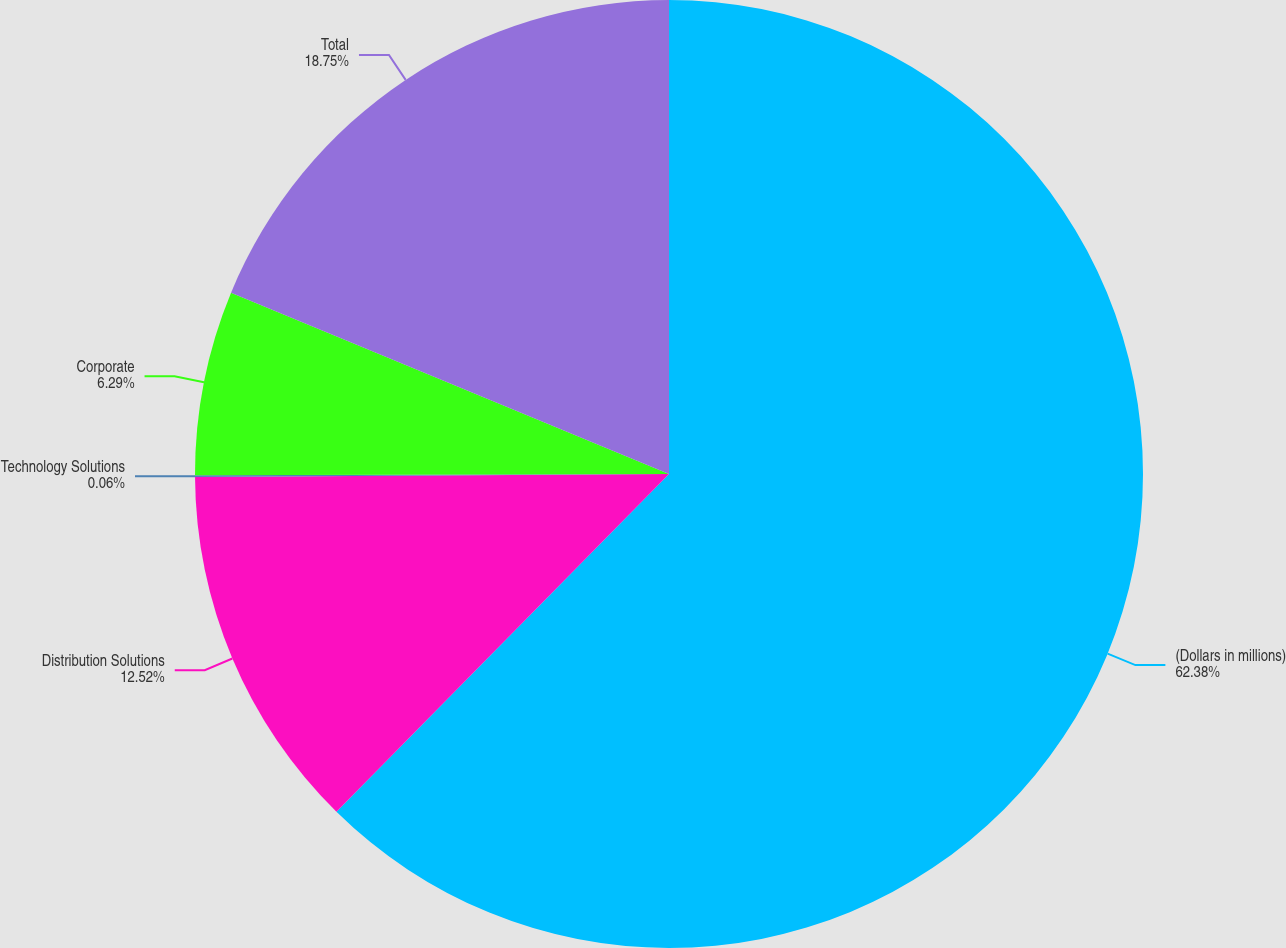Convert chart to OTSL. <chart><loc_0><loc_0><loc_500><loc_500><pie_chart><fcel>(Dollars in millions)<fcel>Distribution Solutions<fcel>Technology Solutions<fcel>Corporate<fcel>Total<nl><fcel>62.37%<fcel>12.52%<fcel>0.06%<fcel>6.29%<fcel>18.75%<nl></chart> 